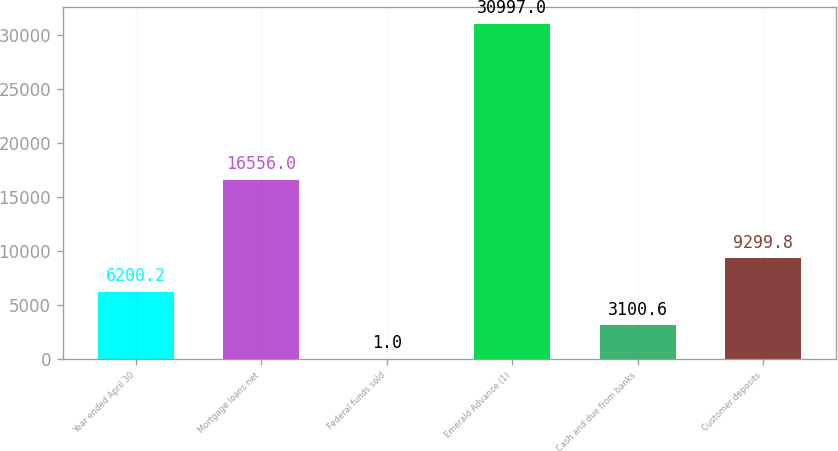Convert chart to OTSL. <chart><loc_0><loc_0><loc_500><loc_500><bar_chart><fcel>Year ended April 30<fcel>Mortgage loans net<fcel>Federal funds sold<fcel>Emerald Advance (1)<fcel>Cash and due from banks<fcel>Customer deposits<nl><fcel>6200.2<fcel>16556<fcel>1<fcel>30997<fcel>3100.6<fcel>9299.8<nl></chart> 